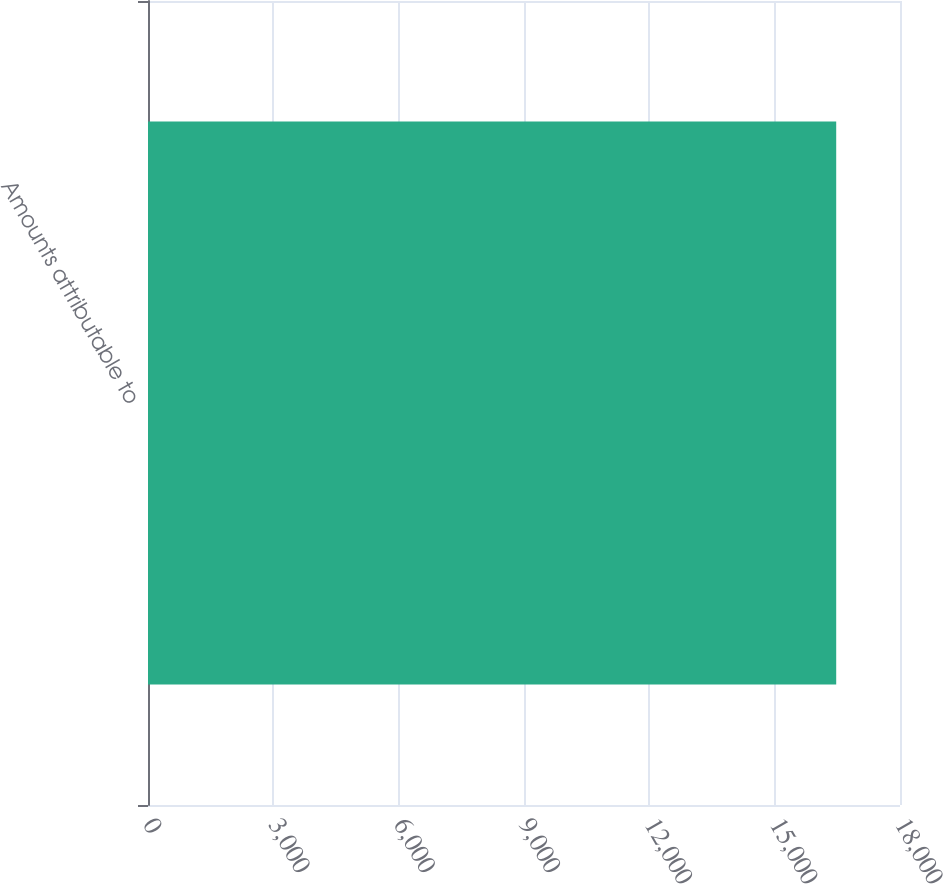<chart> <loc_0><loc_0><loc_500><loc_500><bar_chart><fcel>Amounts attributable to<nl><fcel>16473<nl></chart> 